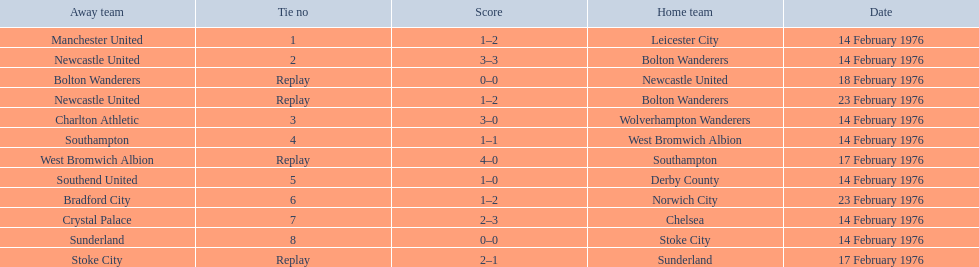What were the home teams in the 1975-76 fa cup? Leicester City, Bolton Wanderers, Newcastle United, Bolton Wanderers, Wolverhampton Wanderers, West Bromwich Albion, Southampton, Derby County, Norwich City, Chelsea, Stoke City, Sunderland. Which of these teams had the tie number 1? Leicester City. 